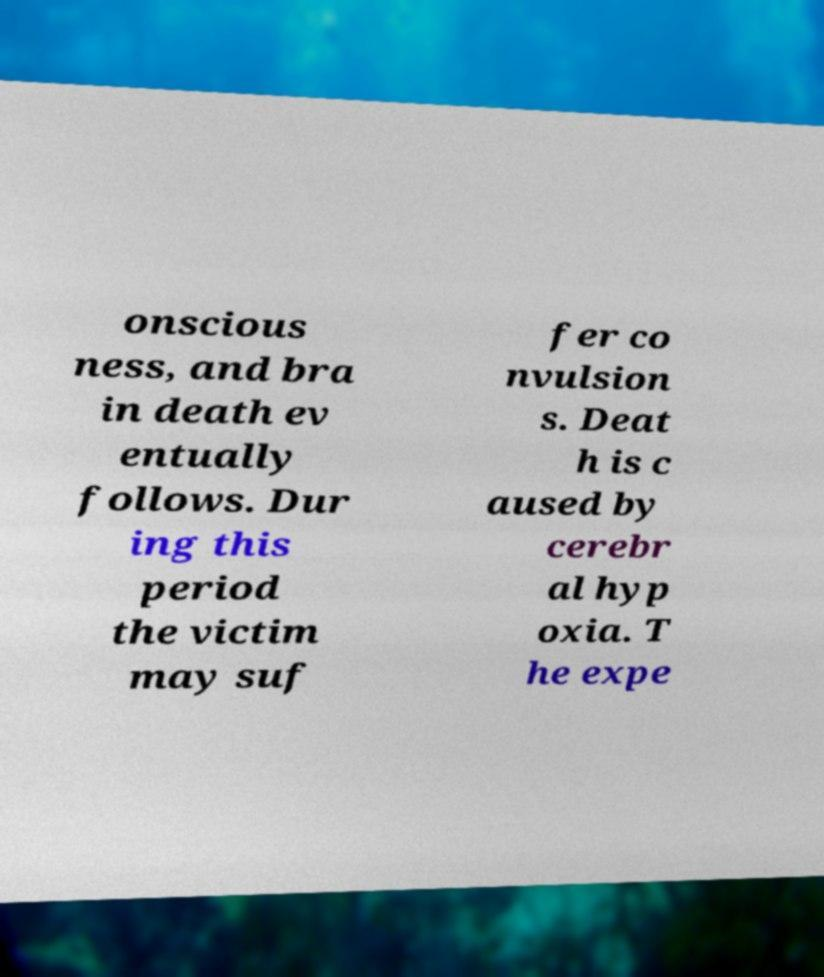Could you extract and type out the text from this image? onscious ness, and bra in death ev entually follows. Dur ing this period the victim may suf fer co nvulsion s. Deat h is c aused by cerebr al hyp oxia. T he expe 